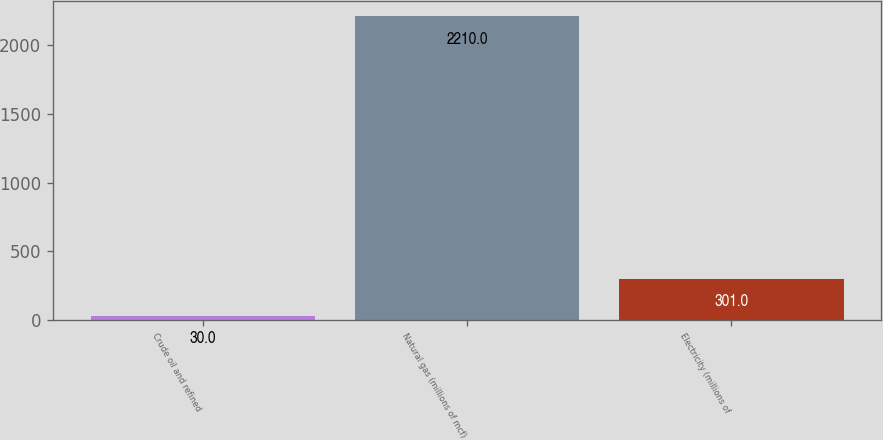Convert chart to OTSL. <chart><loc_0><loc_0><loc_500><loc_500><bar_chart><fcel>Crude oil and refined<fcel>Natural gas (millions of mcf)<fcel>Electricity (millions of<nl><fcel>30<fcel>2210<fcel>301<nl></chart> 